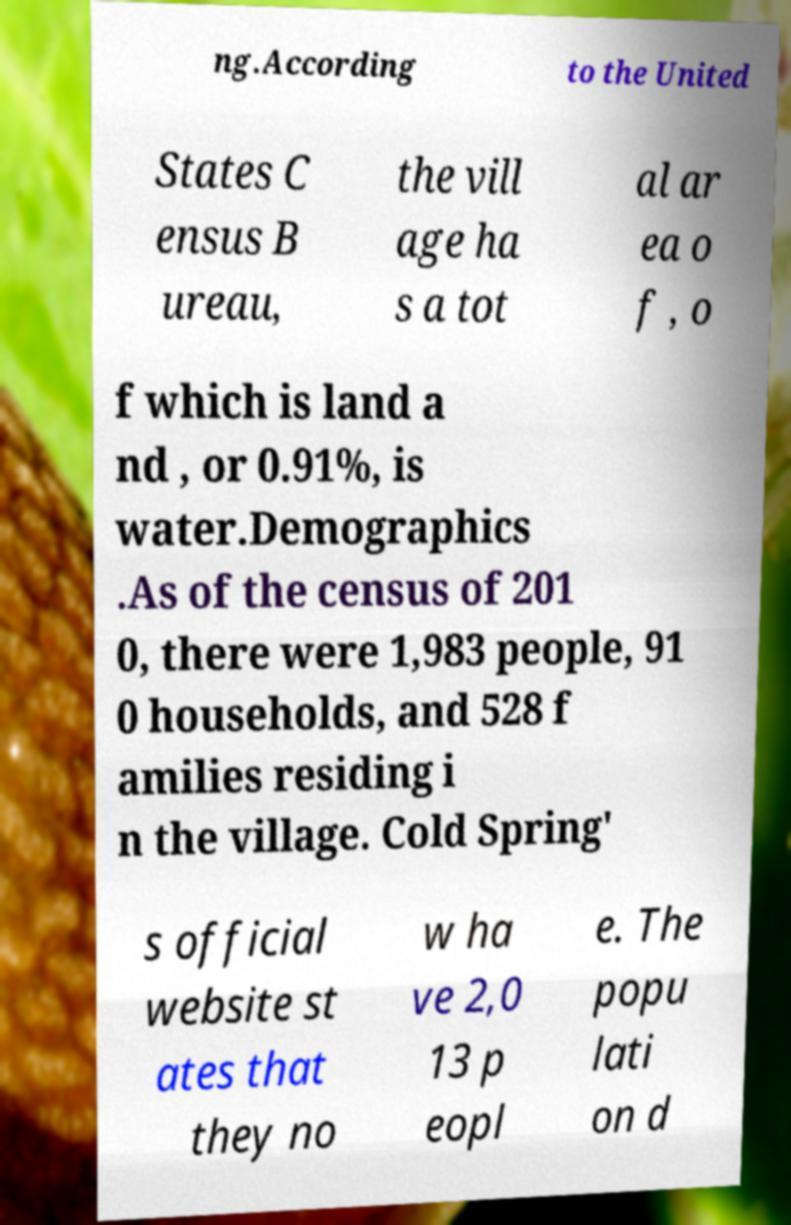For documentation purposes, I need the text within this image transcribed. Could you provide that? ng.According to the United States C ensus B ureau, the vill age ha s a tot al ar ea o f , o f which is land a nd , or 0.91%, is water.Demographics .As of the census of 201 0, there were 1,983 people, 91 0 households, and 528 f amilies residing i n the village. Cold Spring' s official website st ates that they no w ha ve 2,0 13 p eopl e. The popu lati on d 